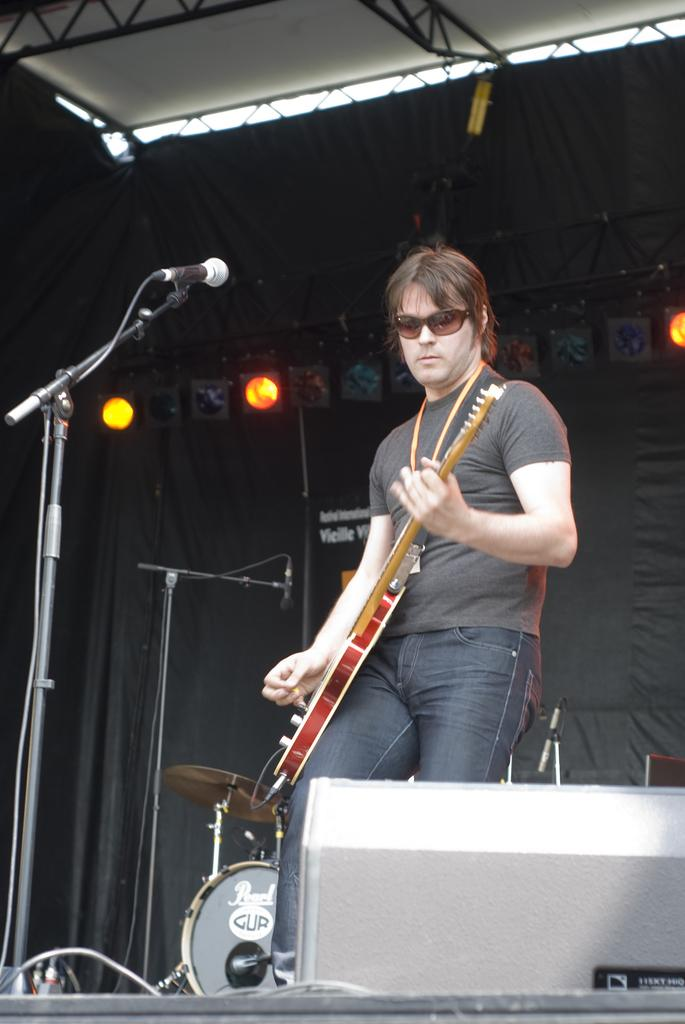What is the man in the image doing? The man is playing a guitar in the image. What object is present near the man? There is a microphone in the image. Where is the man positioned in relation to the microphone? The man is in front of the microphone. What type of setting is the scene taking place in? The scene takes place on a stage. What type of cake is being served to the baby on the stage? There is no cake or baby present in the image; it features a man playing a guitar on a stage with a microphone. What type of fork is the man using to play the guitar? The man is not using a fork to play the guitar; he is using his hands to strum the strings. 